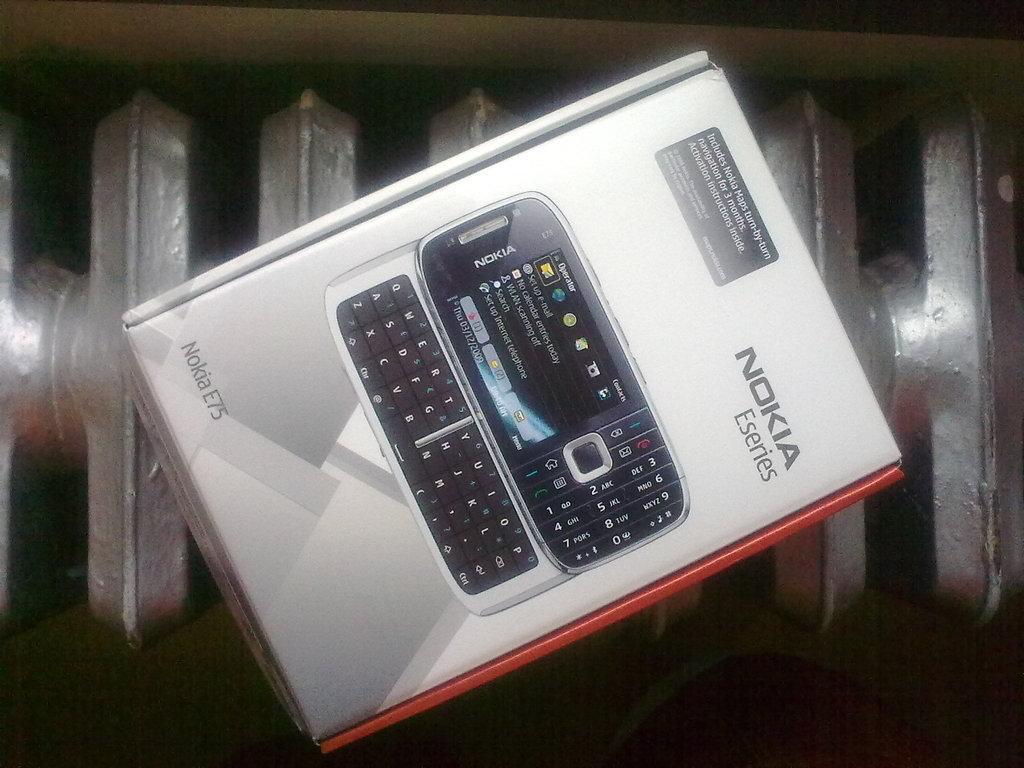Please provide a concise description of this image. In this image there is a box on the surface, there is a mobile phone printed on the box, there is text on the box. 